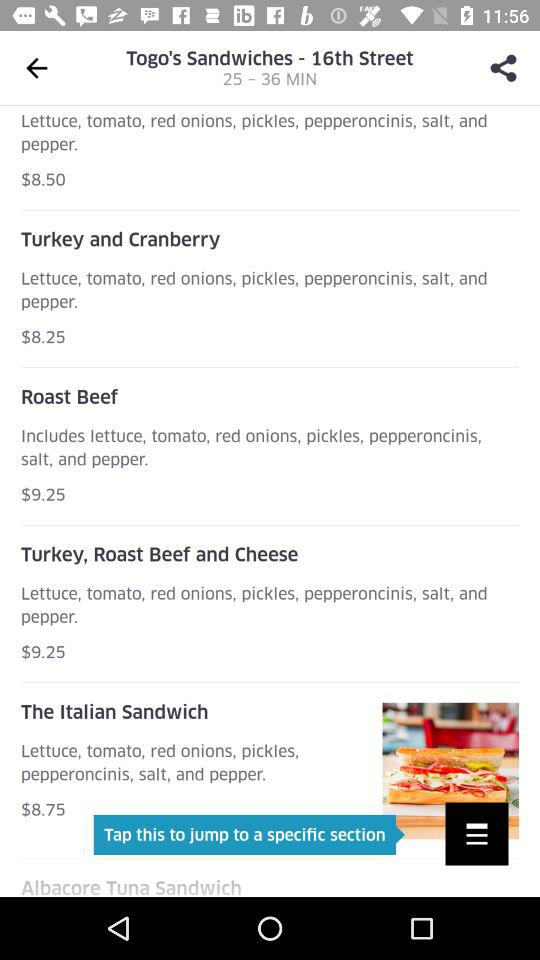What is the preparation time of Togo's Sandwiches recipe? The preparation time of Togo's Sandwiches recipe is 25 -36 minutes. 